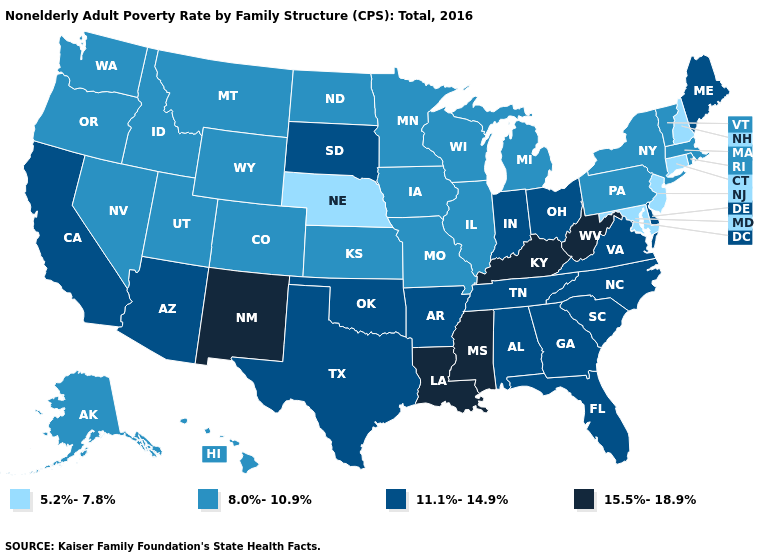Which states hav the highest value in the MidWest?
Short answer required. Indiana, Ohio, South Dakota. Name the states that have a value in the range 11.1%-14.9%?
Quick response, please. Alabama, Arizona, Arkansas, California, Delaware, Florida, Georgia, Indiana, Maine, North Carolina, Ohio, Oklahoma, South Carolina, South Dakota, Tennessee, Texas, Virginia. How many symbols are there in the legend?
Concise answer only. 4. Does Montana have a higher value than New Jersey?
Be succinct. Yes. Which states have the lowest value in the USA?
Quick response, please. Connecticut, Maryland, Nebraska, New Hampshire, New Jersey. Does Arkansas have the same value as Delaware?
Answer briefly. Yes. Does Louisiana have the highest value in the USA?
Quick response, please. Yes. What is the value of Iowa?
Give a very brief answer. 8.0%-10.9%. Among the states that border South Dakota , does Minnesota have the lowest value?
Give a very brief answer. No. What is the highest value in states that border South Carolina?
Concise answer only. 11.1%-14.9%. What is the value of Wisconsin?
Short answer required. 8.0%-10.9%. What is the lowest value in states that border Maine?
Short answer required. 5.2%-7.8%. Does Maryland have the lowest value in the South?
Answer briefly. Yes. Does the first symbol in the legend represent the smallest category?
Concise answer only. Yes. What is the value of Connecticut?
Quick response, please. 5.2%-7.8%. 